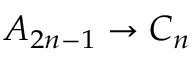Convert formula to latex. <formula><loc_0><loc_0><loc_500><loc_500>A _ { 2 n - 1 } \to C _ { n }</formula> 